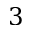Convert formula to latex. <formula><loc_0><loc_0><loc_500><loc_500>3</formula> 